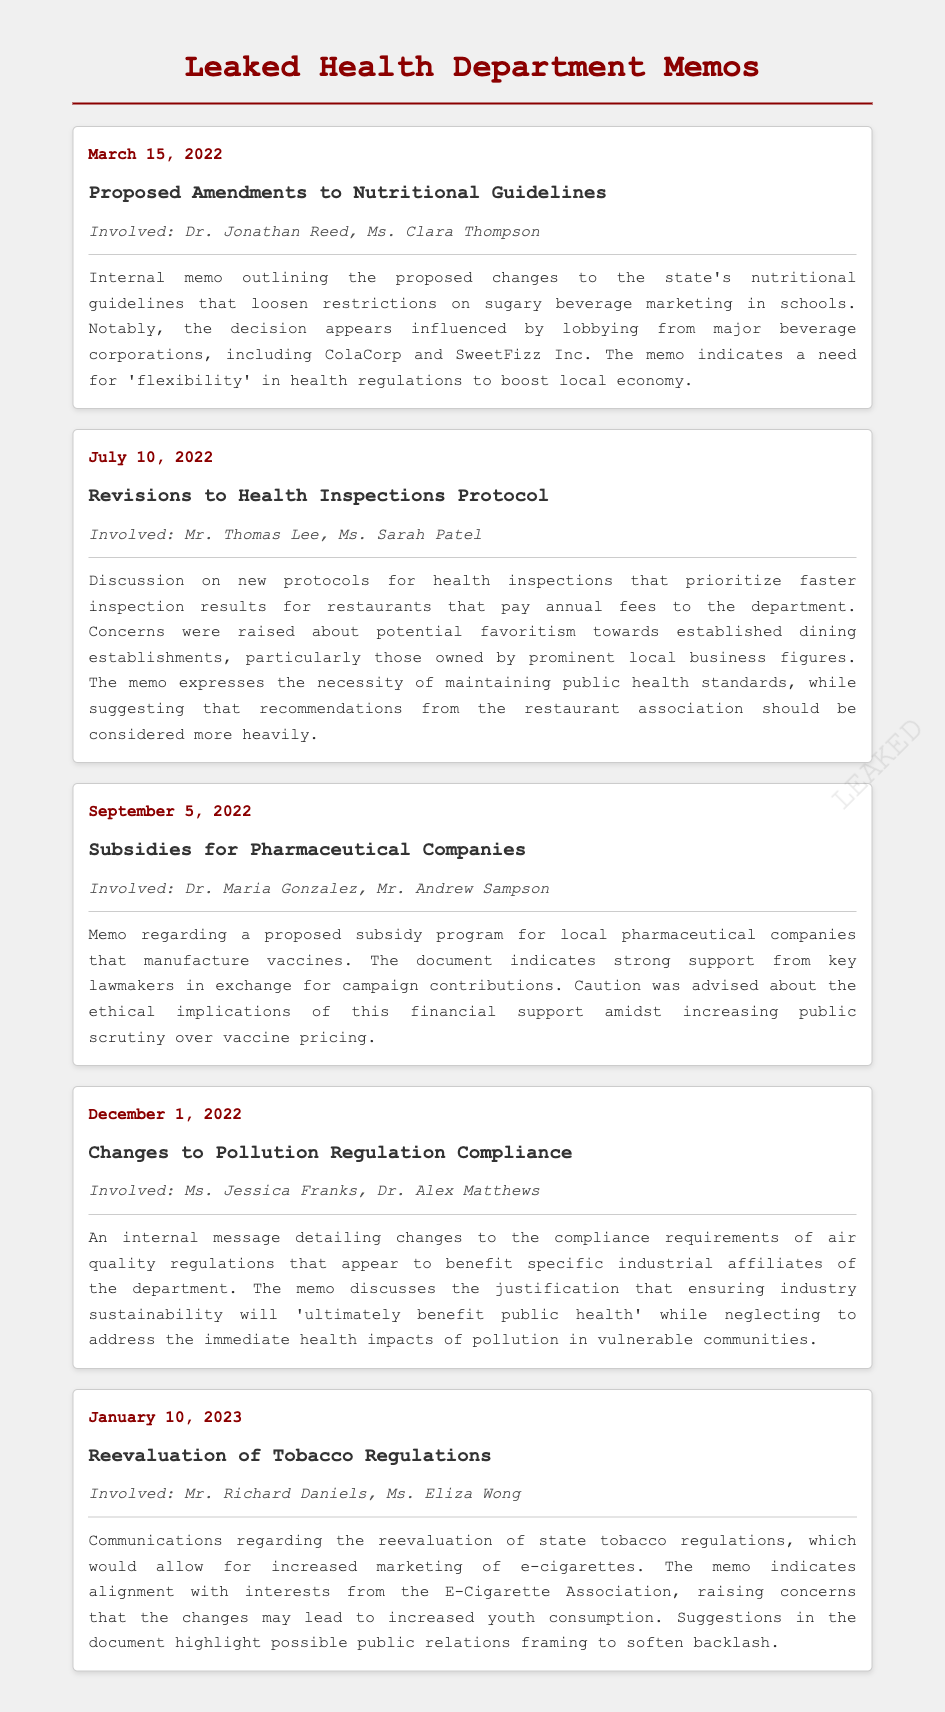What is the date of the first memo? The first memo is dated March 15, 2022.
Answer: March 15, 2022 Who are the involved parties in the memo about tobacco regulations? The involved parties in the tobacco regulations memo are Mr. Richard Daniels and Ms. Eliza Wong.
Answer: Mr. Richard Daniels, Ms. Eliza Wong What is the subject of the July 10, 2022 memo? The subject of the July 10, 2022 memo is Revisions to Health Inspections Protocol.
Answer: Revisions to Health Inspections Protocol What lobbying influence is mentioned in the nutritional guidelines memo? The memo indicates lobbying from major beverage corporations, including ColaCorp and SweetFizz Inc.
Answer: ColaCorp and SweetFizz Inc Which industrial aspect does the December 1, 2022 memo address? The December 1, 2022 memo addresses changes to pollution regulation compliance.
Answer: Pollution regulation compliance What ethical concern is raised regarding the pharmaceutical subsidies? The concern raised is about the ethical implications of financial support amidst increasing public scrutiny over vaccine pricing.
Answer: Ethical implications of financial support Why was there an indication of favoritism in the health inspections memo? It was suggested that faster inspection results would be prioritized for restaurants that pay annual fees.
Answer: Faster inspection results for restaurants that pay annual fees What is a suggested tactic mentioned in the tobacco regulations memo? The memo suggests possible public relations framing to soften backlash against changes.
Answer: Public relations framing to soften backlash 